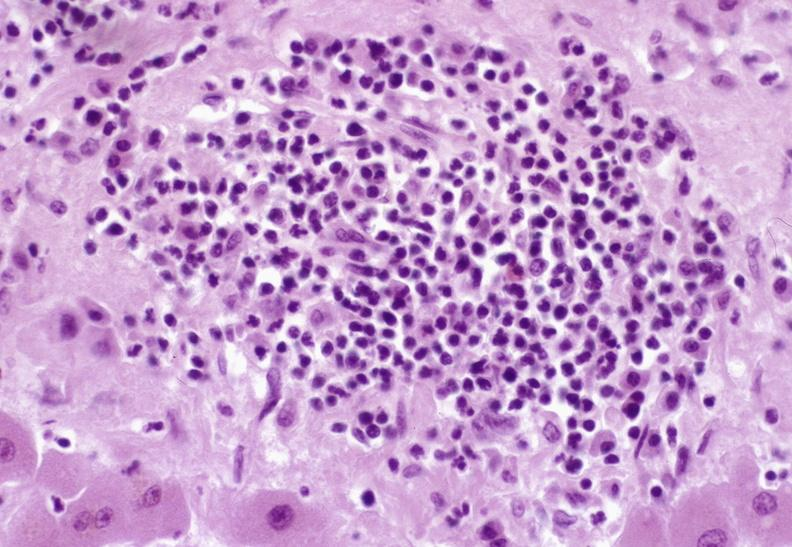s exposure present?
Answer the question using a single word or phrase. No 